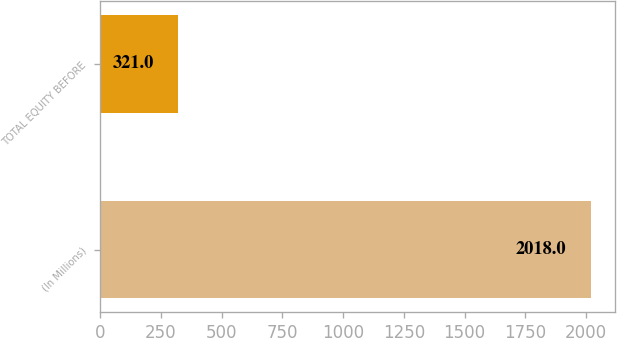Convert chart. <chart><loc_0><loc_0><loc_500><loc_500><bar_chart><fcel>(In Millions)<fcel>TOTAL EQUITY BEFORE<nl><fcel>2018<fcel>321<nl></chart> 